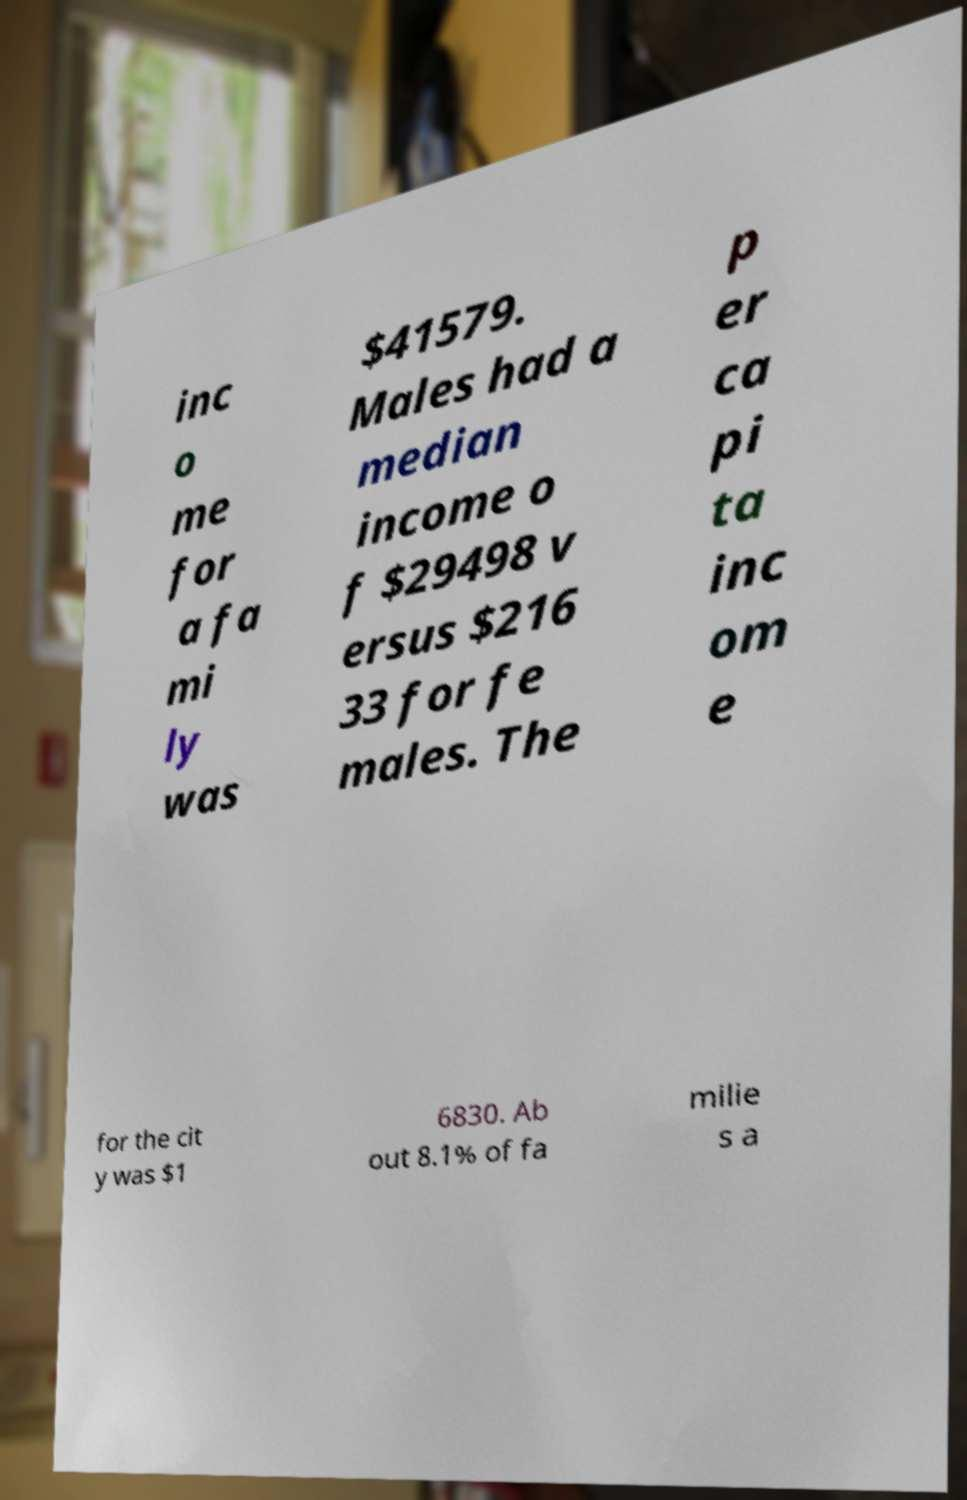Please read and relay the text visible in this image. What does it say? inc o me for a fa mi ly was $41579. Males had a median income o f $29498 v ersus $216 33 for fe males. The p er ca pi ta inc om e for the cit y was $1 6830. Ab out 8.1% of fa milie s a 